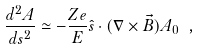Convert formula to latex. <formula><loc_0><loc_0><loc_500><loc_500>\frac { d ^ { 2 } A } { d s ^ { 2 } } \simeq - \frac { Z e } { E } \hat { s } \cdot ( \nabla \times \vec { B } ) A _ { 0 } \ ,</formula> 